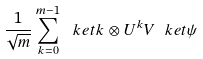Convert formula to latex. <formula><loc_0><loc_0><loc_500><loc_500>\frac { 1 } { \sqrt { m } } \sum _ { k = 0 } ^ { m - 1 } \ k e t { k } \otimes U ^ { k } V \ k e t { \psi }</formula> 